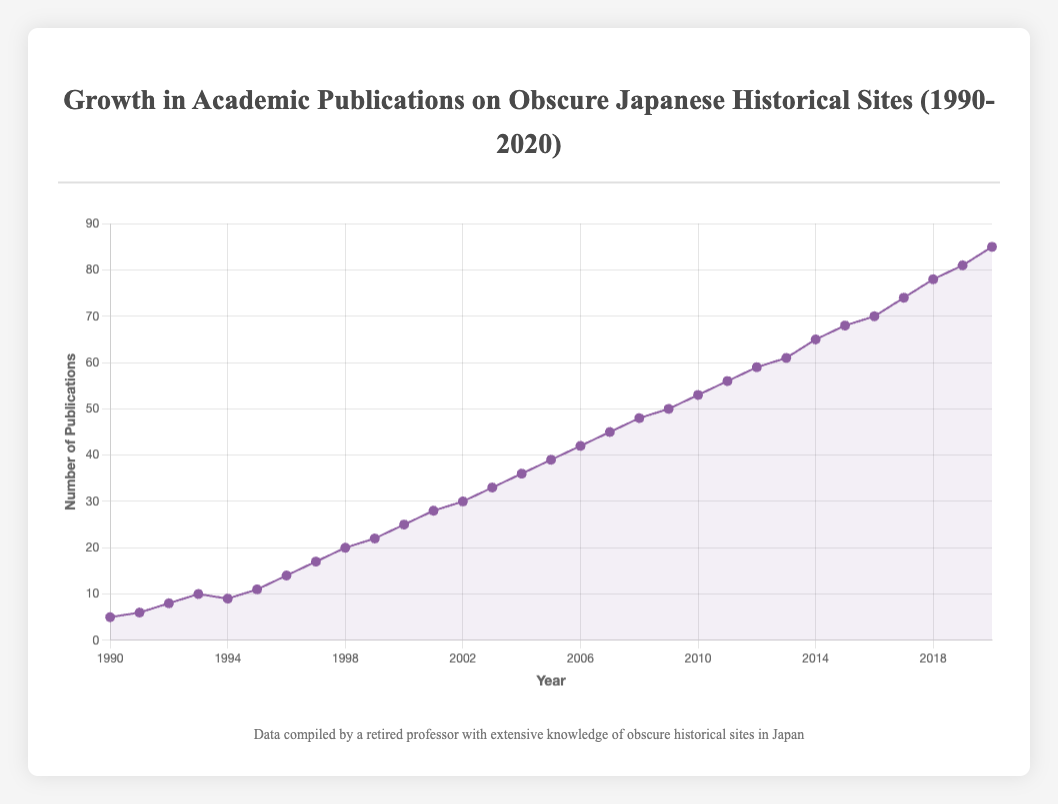Which year saw the highest number of publications? The highest point on the line plot corresponds to the year 2020 with 85 publications.
Answer: 2020 By how many publications did the number of publications increase from 1995 to 2000? In 1995, there were 11 publications, and in 2000, there were 25. Therefore, the increase is 25 - 11 = 14 publications.
Answer: 14 Which decade experienced the greatest increase in the number of publications? From 2000 to 2010, the number of publications rose from 25 to 53, an increase of 28. From 2010 to 2020, it rose from 53 to 85, an increase of 32. Therefore, the greatest increase occurred between 2010 to 2020.
Answer: 2010-2020 What is the average number of publications per year between 1990 and 2000? Sum of publications from 1990 to 2000: 5 + 6 + 8 + 10 + 9 + 11 + 14 + 17 + 20 + 22 + 25 = 147. There are 11 years in this period, so the average is 147 / 11 ≈ 13.36 publications per year.
Answer: 13.36 Compare the number of publications in 1997 and 2007. Which year had more publications and by how many? In 1997, there were 17 publications; in 2007, there were 45. Thus, 2007 had more publications by 45 - 17 = 28.
Answer: 2007, 28 Which year experienced a decrease in the number of publications compared to the previous year? The line dips slightly between 1993 (10 publications) and 1994 (9 publications), indicating a decrease.
Answer: 1994 What is the overall trend of the number of publications over the years? The line plot demonstrates a general upward trend in the number of publications over the years from 1990 to 2020.
Answer: Upward trend 